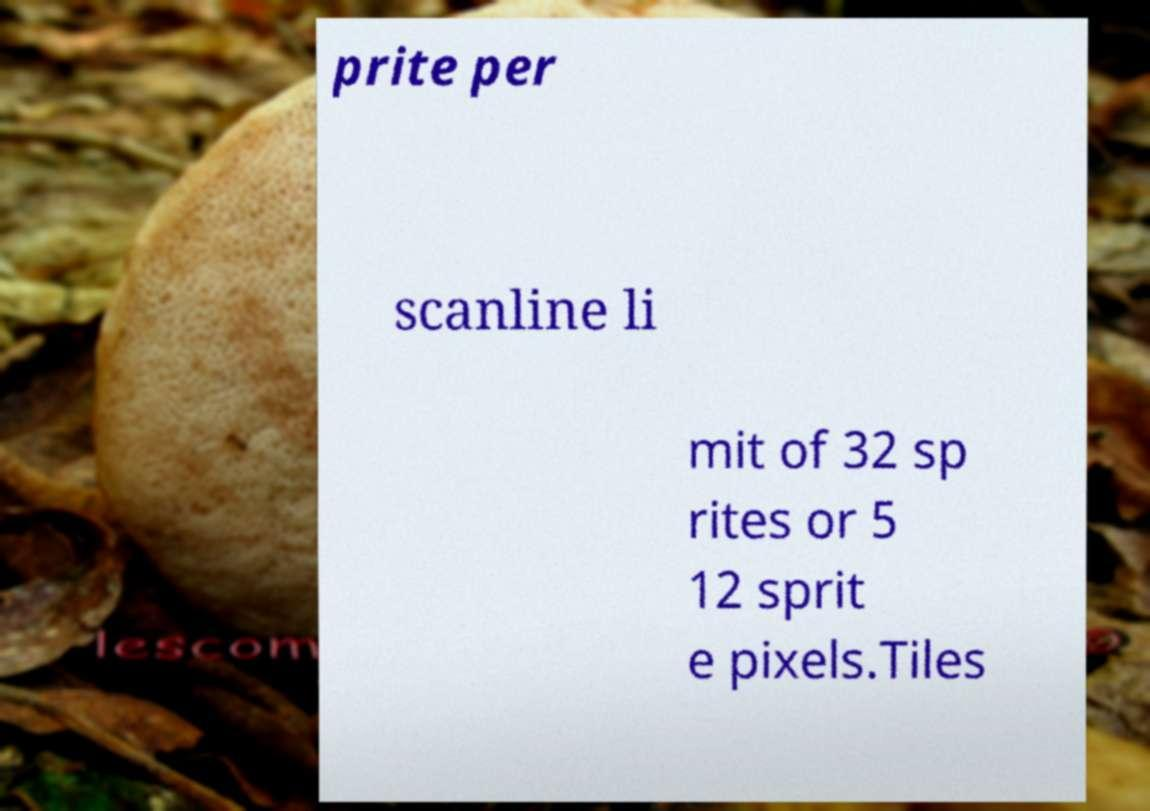I need the written content from this picture converted into text. Can you do that? prite per scanline li mit of 32 sp rites or 5 12 sprit e pixels.Tiles 